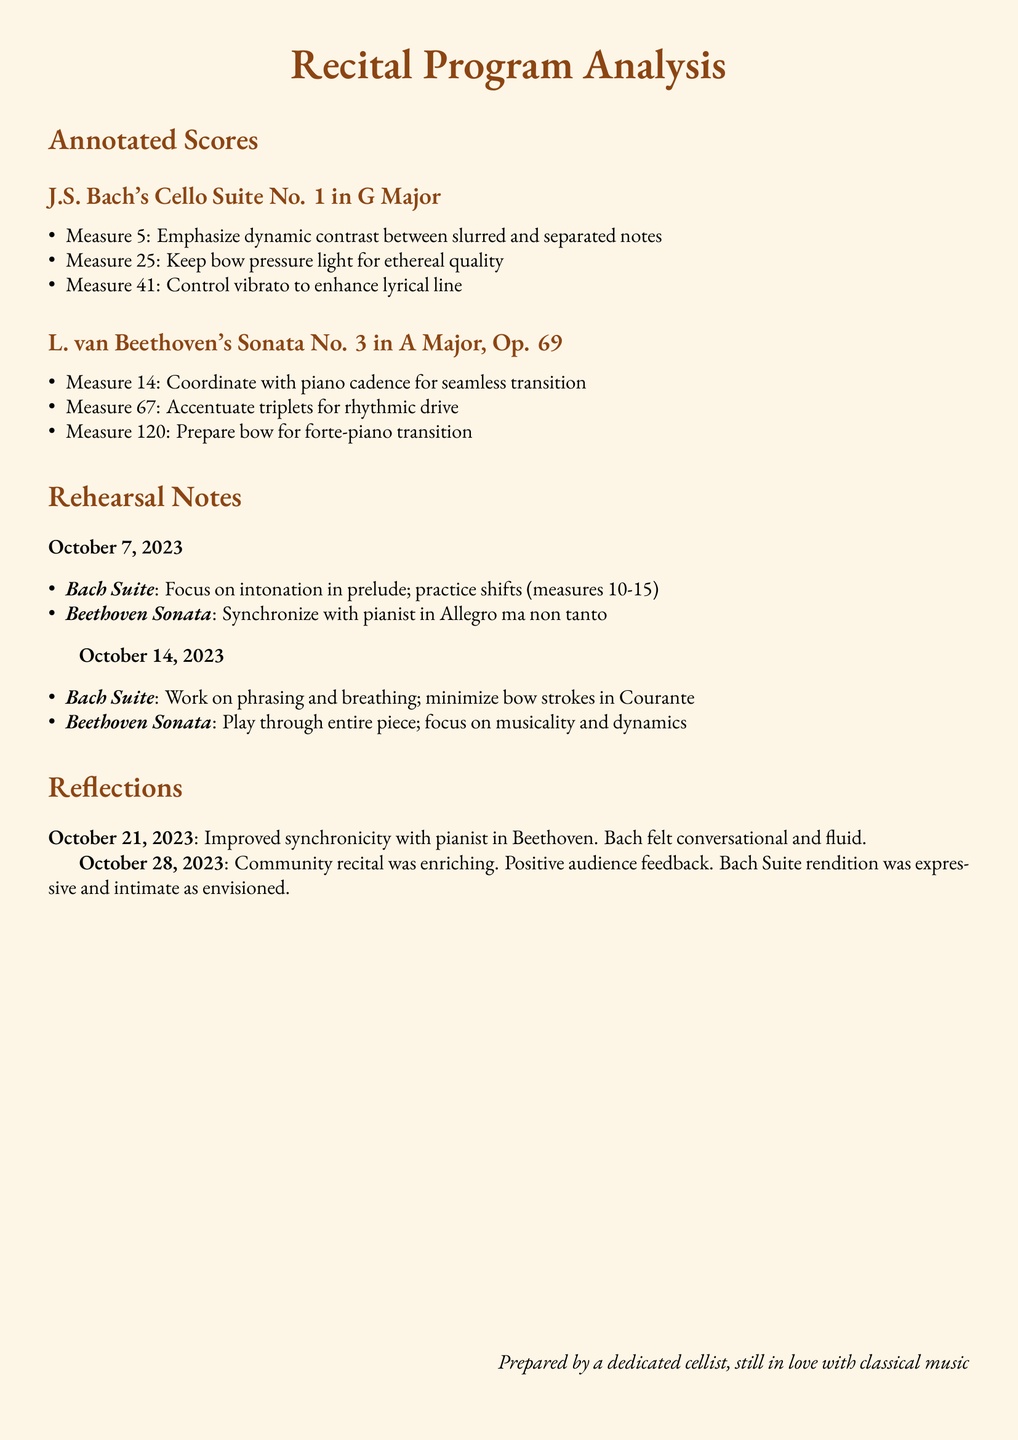What is the title of the first piece in the recital? The title is presented in the section for annotated scores and is identified as "J.S. Bach's Cello Suite No. 1 in G Major."
Answer: J.S. Bach's Cello Suite No. 1 in G Major What measure emphasizes dynamic contrast between slurred and separated notes in Bach's suite? This measure is specifically noted in the annotated scores section.
Answer: Measure 5 How many rehearsal notes are documented in total? The notes are listed under two specific dates, providing a count of the documented sessions.
Answer: 2 What date was the reflection about improved synchronicity with the pianist documented? The reflections section shows the date of this particular entry.
Answer: October 21, 2023 Which piece requires synchronization with the pianist in its Allegro ma non tanto section? This detail can be found in the rehearsal notes for October 7, 2023.
Answer: Beethoven Sonata What is noted to keep light in Measure 25 of Bach's suite? This detail corresponds to the performance technique highlighted specifically for that measure.
Answer: Bow pressure What was the feedback received during the community recital? The reflection mentions the audience's response to the performance.
Answer: Positive audience feedback What specific focus is noted for the Bach Suite on October 14, 2023? This focus is detailed in the rehearsal notes for that date.
Answer: Phrasing and breathing 